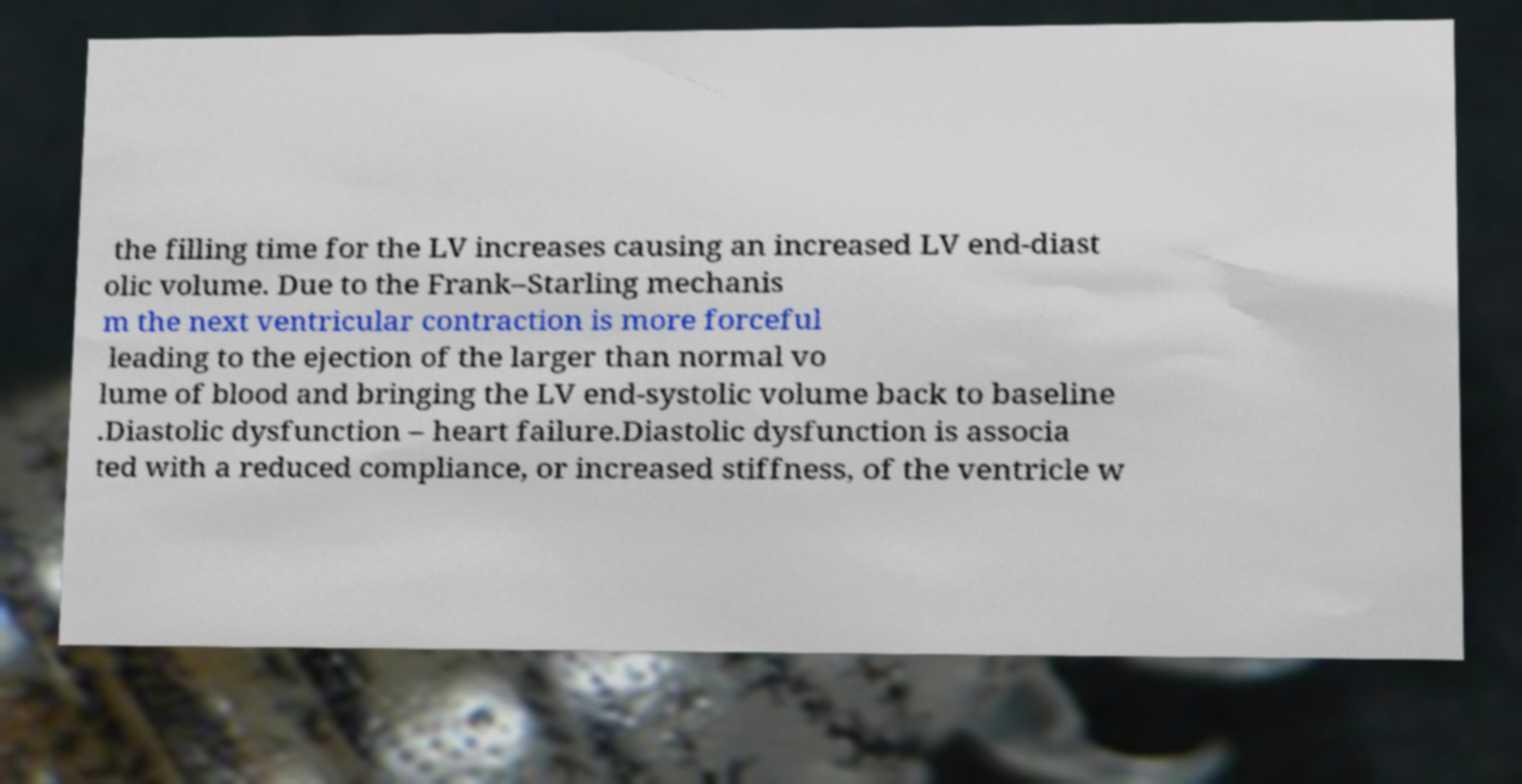Could you extract and type out the text from this image? the filling time for the LV increases causing an increased LV end-diast olic volume. Due to the Frank–Starling mechanis m the next ventricular contraction is more forceful leading to the ejection of the larger than normal vo lume of blood and bringing the LV end-systolic volume back to baseline .Diastolic dysfunction – heart failure.Diastolic dysfunction is associa ted with a reduced compliance, or increased stiffness, of the ventricle w 